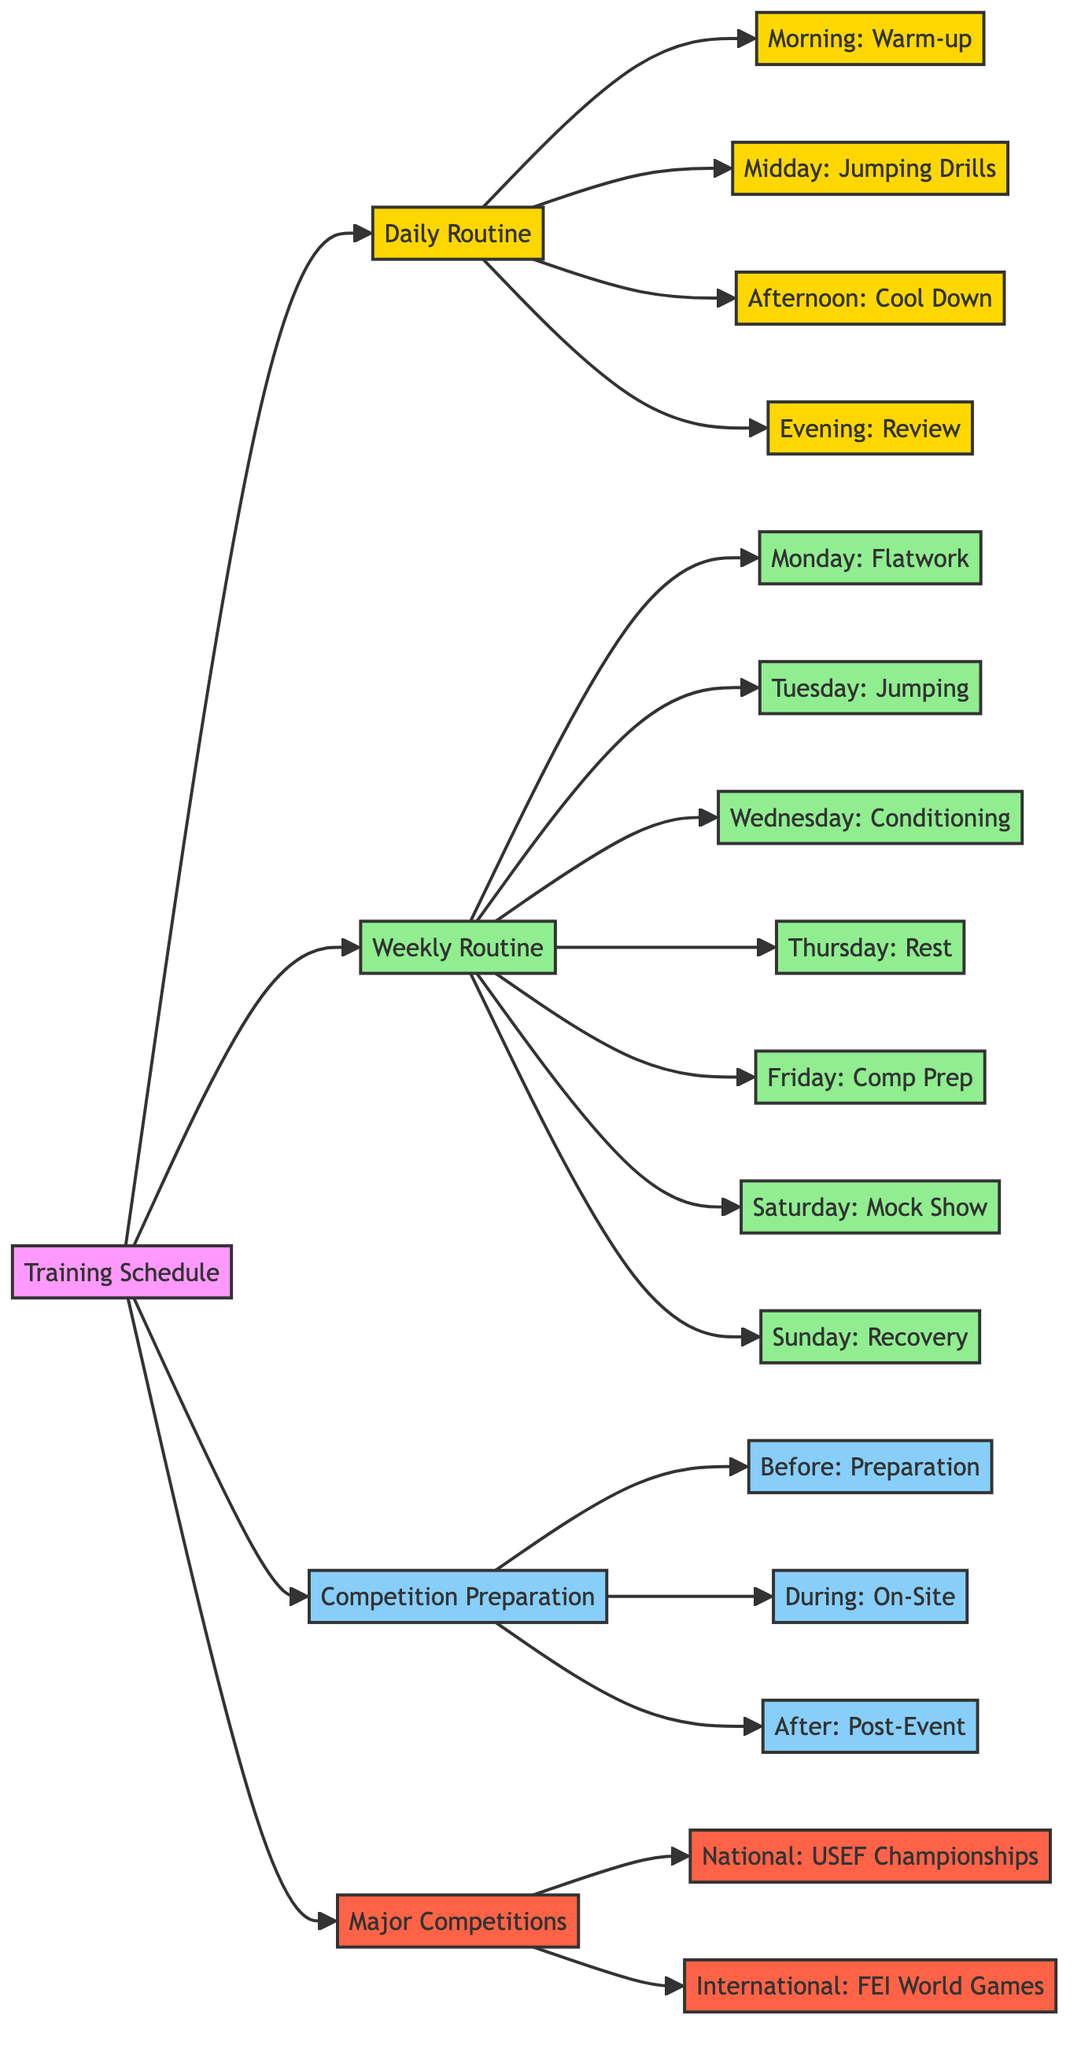What activities are included in the morning routine? The morning routine branches from 'Daily Routine' and lists the activity as 'Warm-up exercises', which includes components like 'Stretching', 'Light Cardio', and 'Horse Grooming'.
Answer: Warm-up exercises How many days are there in the weekly routine? The weekly routine lists activities for each day from Monday to Sunday, which totals seven days.
Answer: 7 What is the activity scheduled for Tuesday? Looking under the 'Weekly Routine', the box for Tuesday shows the activity as 'Jumping Technique', which includes components like 'Individual Jump Practice' and 'Position Work'.
Answer: Jumping Technique What happens during the 'During Competition' phase? This is part of the 'Competition Preparation' flow. The node 'During: On-Site' lists activities like 'Warm-Up', 'Course Walk', and 'Hydration'.
Answer: On-Site Routine What is the main focus of Friday's training schedule? In the 'Weekly Routine', Friday is dedicated to 'Competition Prep', which encompasses components like 'Course Simulation' and 'Mental Exercises'.
Answer: Competition Prep What type of competition is represented at the international level? Under 'Major Competitions', the international level lists the competition as 'FEI World Equestrian Games', indicating its significance in the competition hierarchy.
Answer: FEI World Equestrian Games How many activities are described in the afternoon routine? The 'Afternoon' part of the 'Daily Routine' includes the activity called 'Cool Down', which has three components: 'Gentle Trot', 'Walking', and 'Post-Ride Grooming'. Thus, there are three activities.
Answer: 3 What is part of the pre-competition routine? Under 'Before: Preparation' in the ‘Competition Preparation’ section, the components include 'Packing Gear', 'Health Check', and 'Strategy Planning', indicating the necessary preparations prior to competing.
Answer: Pre-Competition Routine 